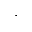<formula> <loc_0><loc_0><loc_500><loc_500>,</formula> 